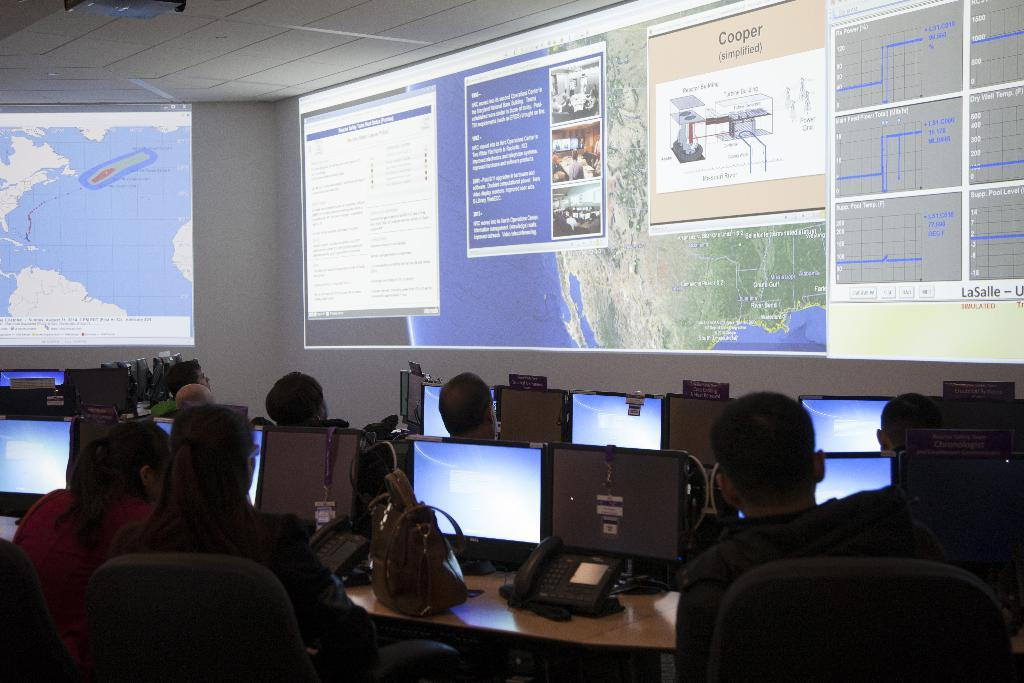What are the people in the image doing? The persons in the image are sitting on chairs. What is on the table in the image? There are monitors on the table. What is the purpose of the monitors? The monitors are likely used for displaying information or visuals. What is visible on the wall in the image? There is a screen visible on the wall. What is the general setting of the image? The image appears to depict a room with chairs, a table, monitors, and a wall with a screen. Can you see any ants crawling on the table in the image? There are no ants visible in the image; the focus is on the persons, chairs, table, monitors, and screen. 